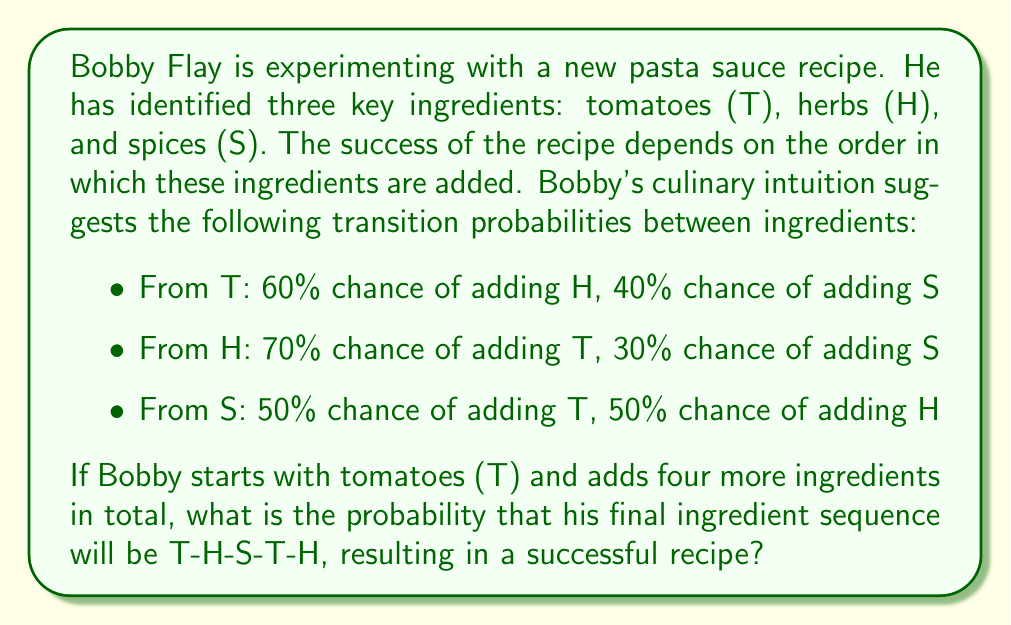Solve this math problem. Let's approach this step-by-step using Markov chains:

1) First, we need to identify the sequence of transitions:
   T → H → S → T → H

2) Now, let's calculate the probability of each transition:

   P(T → H) = 0.60
   P(H → S) = 0.30
   P(S → T) = 0.50
   P(T → H) = 0.60

3) In a Markov chain, the probability of a sequence of events is the product of the individual transition probabilities:

   $$P(T-H-S-T-H) = P(T → H) \cdot P(H → S) \cdot P(S → T) \cdot P(T → H)$$

4) Substituting the values:

   $$P(T-H-S-T-H) = 0.60 \cdot 0.30 \cdot 0.50 \cdot 0.60$$

5) Calculating the final probability:

   $$P(T-H-S-T-H) = 0.054 = 5.4\%$$

Therefore, the probability that Bobby's final ingredient sequence will be T-H-S-T-H is 5.4%.
Answer: 0.054 or 5.4% 